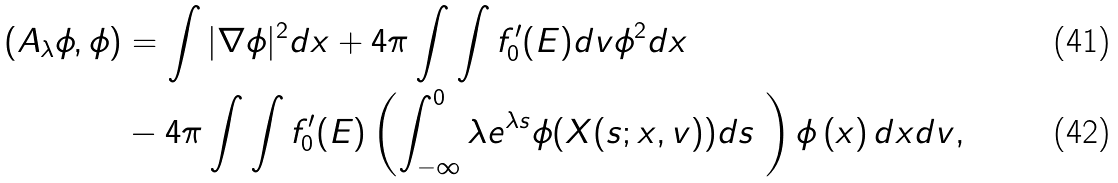<formula> <loc_0><loc_0><loc_500><loc_500>( A _ { \lambda } \phi , \phi ) & = \int | \nabla \phi | ^ { 2 } d x + 4 \pi \int \int f _ { 0 } ^ { \prime } ( E ) d v \phi ^ { 2 } d x \\ & - 4 \pi \int \int f _ { 0 } ^ { \prime } ( E ) \left ( \int _ { - \infty } ^ { 0 } \lambda e ^ { \lambda s } \phi ( X ( s ; x , v ) ) d s \ \right ) \phi \left ( x \right ) d x d v ,</formula> 